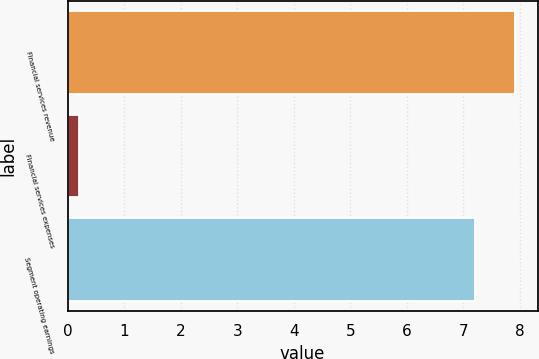<chart> <loc_0><loc_0><loc_500><loc_500><bar_chart><fcel>Financial services revenue<fcel>Financial services expenses<fcel>Segment operating earnings<nl><fcel>7.92<fcel>0.2<fcel>7.2<nl></chart> 